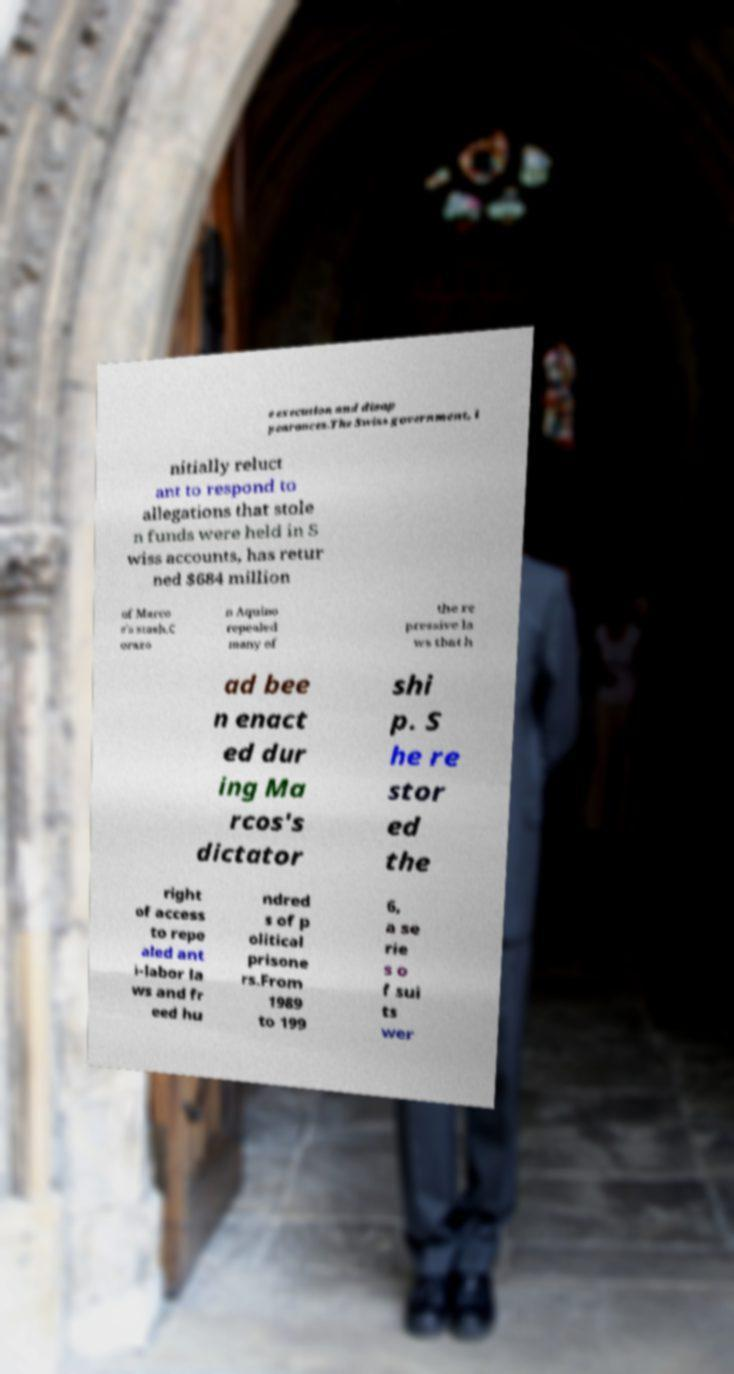Can you read and provide the text displayed in the image?This photo seems to have some interesting text. Can you extract and type it out for me? e execution and disap pearances.The Swiss government, i nitially reluct ant to respond to allegations that stole n funds were held in S wiss accounts, has retur ned $684 million of Marco s's stash.C orazo n Aquino repealed many of the re pressive la ws that h ad bee n enact ed dur ing Ma rcos's dictator shi p. S he re stor ed the right of access to repe aled ant i-labor la ws and fr eed hu ndred s of p olitical prisone rs.From 1989 to 199 6, a se rie s o f sui ts wer 